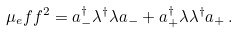<formula> <loc_0><loc_0><loc_500><loc_500>\mu _ { e } f f ^ { 2 } = a _ { - } ^ { \dagger } \lambda ^ { \dagger } \lambda a _ { - } + a _ { + } ^ { \dagger } \lambda \lambda ^ { \dagger } a _ { + } \, .</formula> 